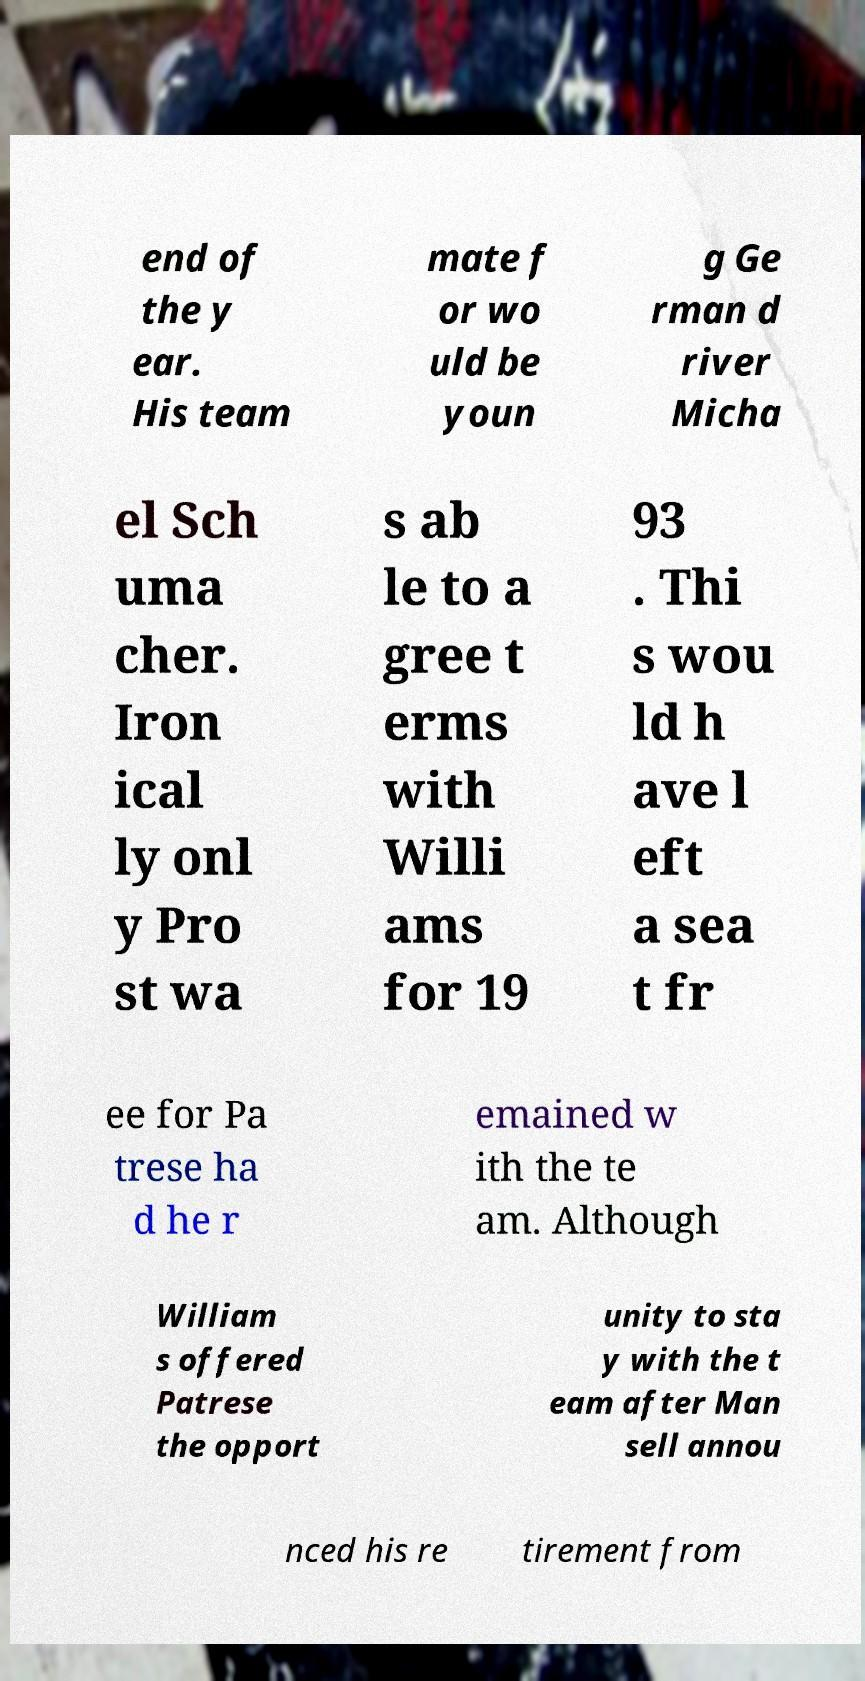Could you extract and type out the text from this image? end of the y ear. His team mate f or wo uld be youn g Ge rman d river Micha el Sch uma cher. Iron ical ly onl y Pro st wa s ab le to a gree t erms with Willi ams for 19 93 . Thi s wou ld h ave l eft a sea t fr ee for Pa trese ha d he r emained w ith the te am. Although William s offered Patrese the opport unity to sta y with the t eam after Man sell annou nced his re tirement from 